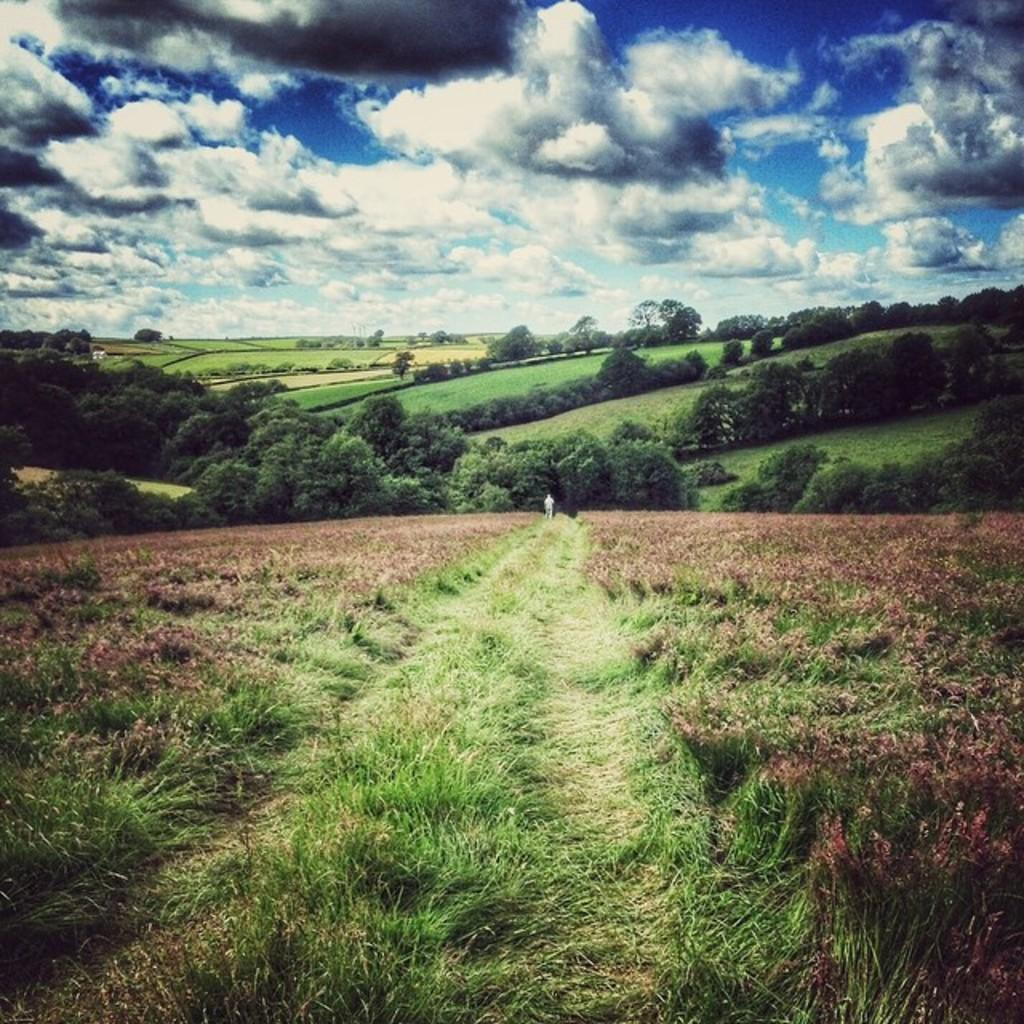What type of vegetation is visible in the front of the image? There is grass in the front of the image. What type of vegetation is visible at the back of the image? There are trees at the back of the image. Can you describe the person in the image? A person is standing in the center of the image. What is visible in the sky in the image? There are clouds in the sky. Where is the desk located in the image? There is no desk present in the image. What type of bone can be seen in the person's hand in the image? There is no bone visible in the person's hand in the image. 